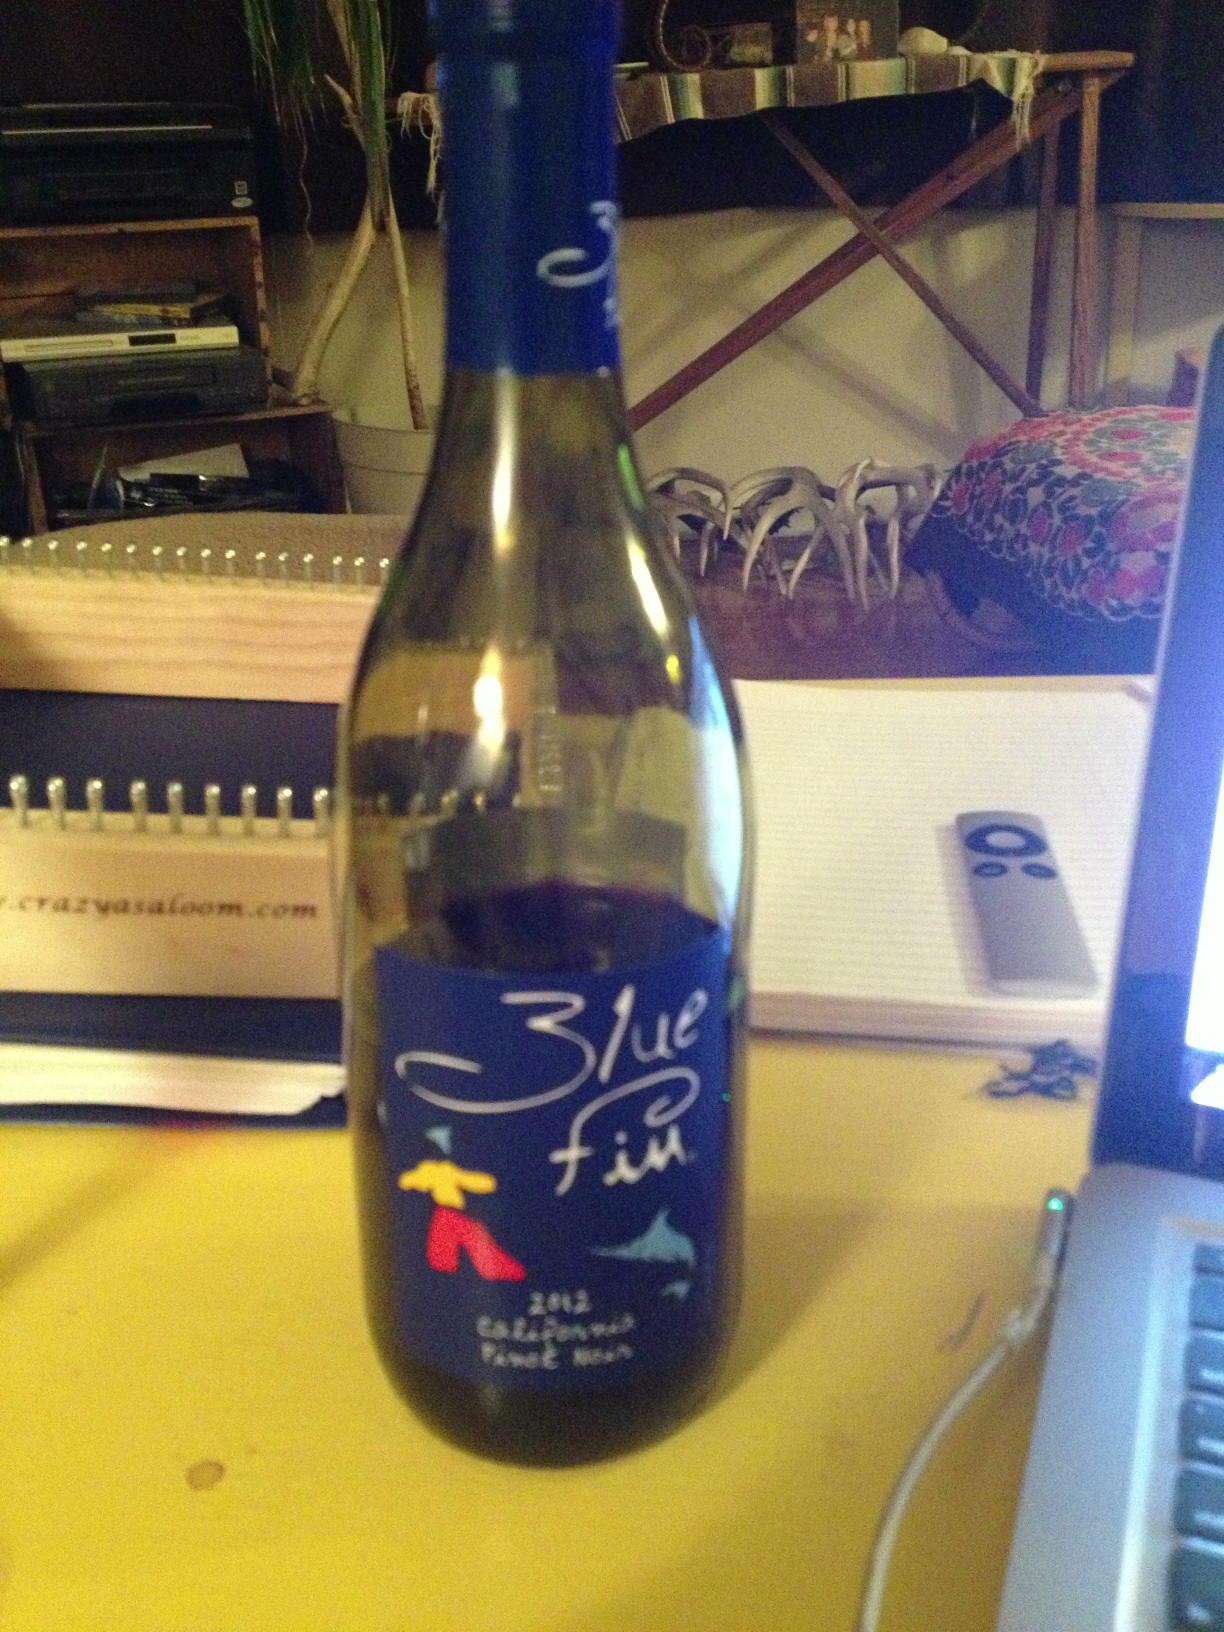Is 'Blue Fin' a widely recognized wine brand? Blue Fin is known in the market but it's not among the most high-profile brands. It offers affordable options for everyday wine enthusiasts. 